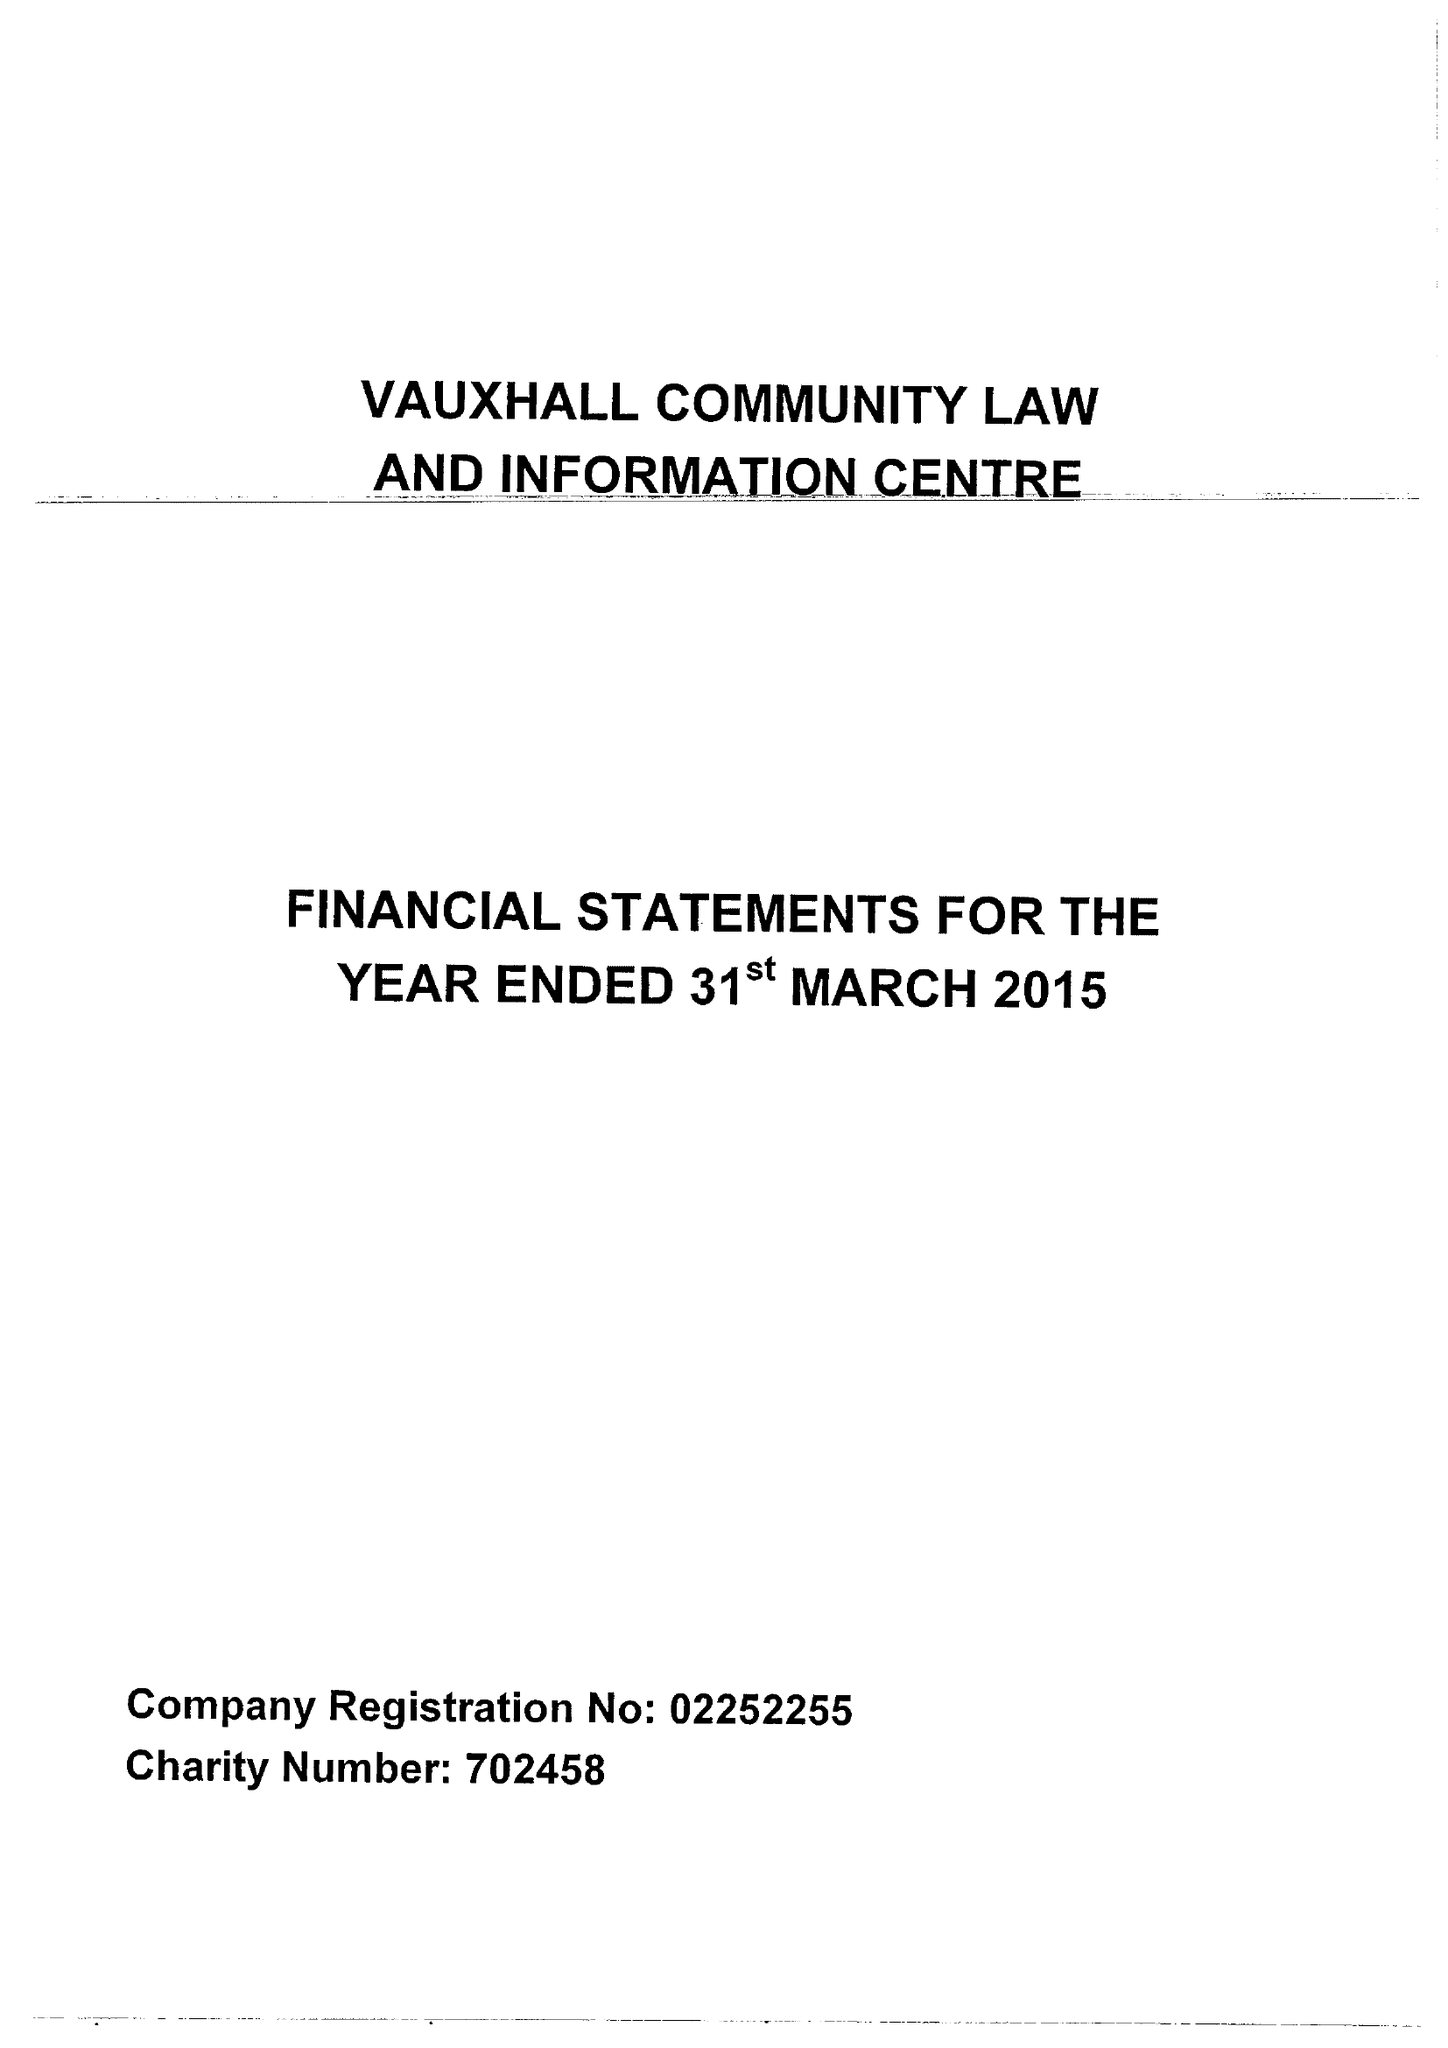What is the value for the address__street_line?
Answer the question using a single word or phrase. BLENHEIM STREET 